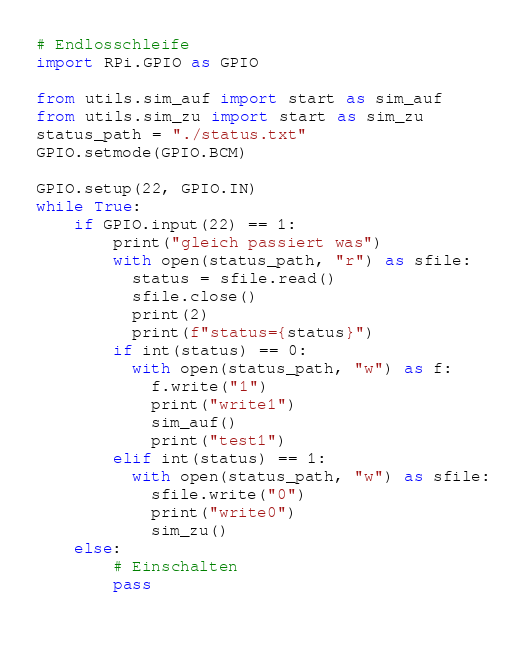Convert code to text. <code><loc_0><loc_0><loc_500><loc_500><_Python_># Endlosschleife
import RPi.GPIO as GPIO

from utils.sim_auf import start as sim_auf
from utils.sim_zu import start as sim_zu
status_path = "./status.txt"
GPIO.setmode(GPIO.BCM)

GPIO.setup(22, GPIO.IN)
while True:
    if GPIO.input(22) == 1:
        print("gleich passiert was")
        with open(status_path, "r") as sfile:
          status = sfile.read()
          sfile.close()
          print(2)
          print(f"status={status}")
        if int(status) == 0:
          with open(status_path, "w") as f:
            f.write("1")
            print("write1")
            sim_auf()
            print("test1")
        elif int(status) == 1:
          with open(status_path, "w") as sfile:
            sfile.write("0")
            print("write0")
            sim_zu()
    else:
        # Einschalten
        pass
    </code> 